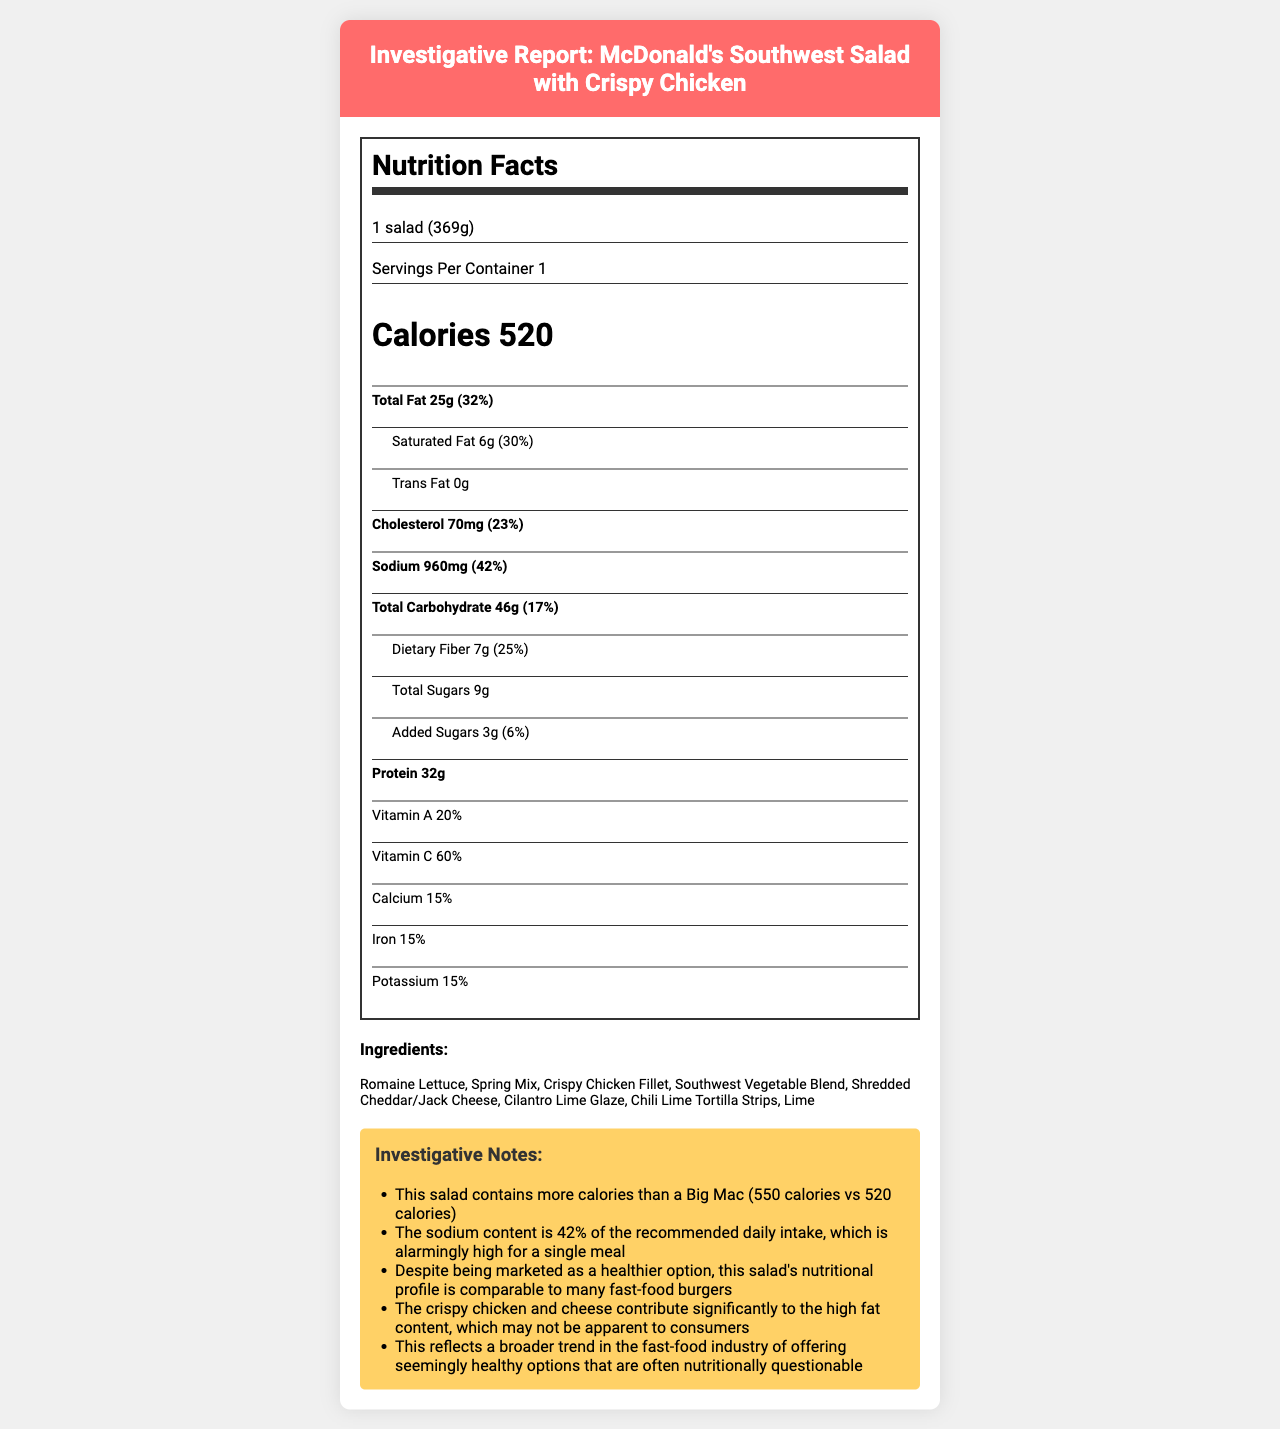what is the serving size for the McDonald's Southwest Salad with Crispy Chicken? The serving size is clearly stated in the section of the document that details nutrition facts, specifically in the description "1 salad (369g)".
Answer: 1 salad (369g) how many calories are in the McDonald's Southwest Salad with Crispy Chicken? The document states that the salad contains 520 calories, which can be found in the "Calories" section.
Answer: 520 what percentage of the daily value of sodium does the McDonald's Southwest Salad with Crispy Chicken contain? The sodium content is listed as 960mg with a daily value percentage of 42%.
Answer: 42% what ingredients are used in the McDonald's Southwest Salad with Crispy Chicken? The ingredients are listed in the ingredients section of the document.
Answer: Romaine Lettuce, Spring Mix, Crispy Chicken Fillet, Southwest Vegetable Blend, Shredded Cheddar/Jack Cheese, Cilantro Lime Glaze, Chili Lime Tortilla Strips, Lime what is the total amount of fat in the McDonald's Southwest Salad with Crispy Chicken? The total amount of fat is found in the section describing "Total Fat," which lists the amount as 25g.
Answer: 25g When compared to a Big Mac, does the McDonald's Southwest Salad with Crispy Chicken have more or less calories? A. More B. Less C. Same D. Cannot be determined The investigative notes mention that the Southwest Salad has 520 calories, while a Big Mac has 550 calories, indicating the salad has fewer calories.
Answer: B Which of the following nutrients is present in the highest daily value percentage in the McDonald's Southwest Salad with Crispy Chicken? i. Saturated Fat ii. Sodium iii. Dietary Fiber iv. Vitamin C The daily value percentage for Vitamin C is 60%, which is higher than Saturated Fat (30%), Sodium (42%), and Dietary Fiber (25%).
Answer: iv. Vitamin C Is the sodium content of McDonald's Southwest Salad with Crispy Chicken considered high? Yes/No The sodium content is 960mg, which is 42% of the recommended daily intake, deemed alarmingly high for a single meal.
Answer: Yes Summarize the main investigation points presented about McDonald's Southwest Salad with Crispy Chicken. The investigative notes provide insights, highlighting high calorie and sodium content, misleading marketing as a healthy option despite its comparable nutritional profile to fast-food burgers. The salad also hides its fat content through ingredients like crispy chicken and cheese, a common trend in the fast-food industry.
Answer: Despite being marketed as a healthy option, McDonald's Southwest Salad with Crispy Chicken contains high calories and sodium content comparable to many fast-food burgers. The calories are only marginally lower than a Big Mac's, and the sodium content is alarmingly high at 42% of daily intake. The salad's high fat content is largely due to the crispy chicken and cheese. This trend reflects a broader industry pattern of seemingly healthy offerings that may not be truly nutritious. What is the percentage of daily vitamin A provided by the McDonald's Southwest Salad with Crispy Chicken? The percentage of daily vitamin A is listed in the nutrition facts section of the document, specifically stating 20%.
Answer: 20% How is the fat content broken down in McDonald's Southwest Salad with Crispy Chicken? The document lists "Total Fat" as 25g and breaks it down further to 6g of "Saturated Fat" and 0g of "Trans Fat" under the respective sections.
Answer: The salad has 25g of total fat, including 6g of saturated fat and 0g of trans fat. What is the main ingredient contributing to the high sodium content in McDonald's Southwest Salad with Crispy Chicken? The document does not provide specific information about which ingredient contributes the most to the sodium content; it only lists general nutritional information and ingredients.
Answer: Cannot be determined To what trend in the fast-food industry does this salad's nutrition profile contribute? The investigative notes explicitly mention that this salad reflects a broader industry trend of marketing seemingly healthy options that may contain questionable nutritional profiles.
Answer: Offering seemingly healthy options that are often nutritionally questionable. 